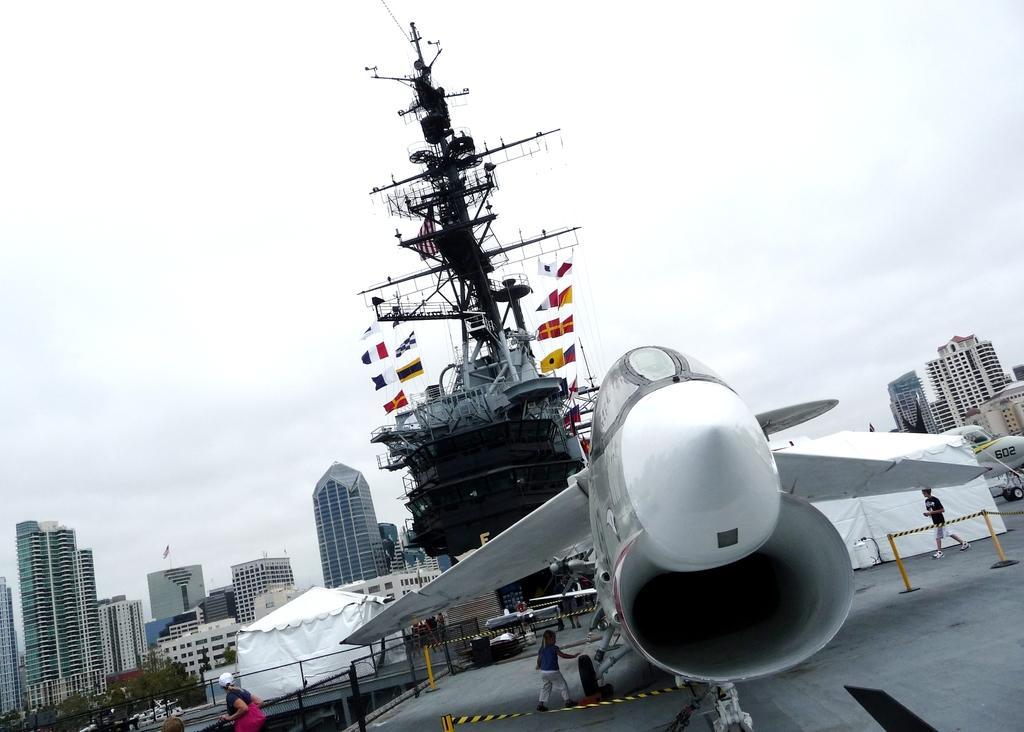Could you give a brief overview of what you see in this image? In the picture we can see an aircraft which is parked on the path and near it, we can a person is standing, and behind the aircraft we can see the pole with some objects and some flags to it and beside it, we can see the tent and far away from it we can see some tower buildings and near it we can see some trees and in the background we can see the sky with clouds. 